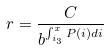<formula> <loc_0><loc_0><loc_500><loc_500>r = \frac { C } { b ^ { \int _ { i _ { 3 } } ^ { x } P ( i ) d i } }</formula> 